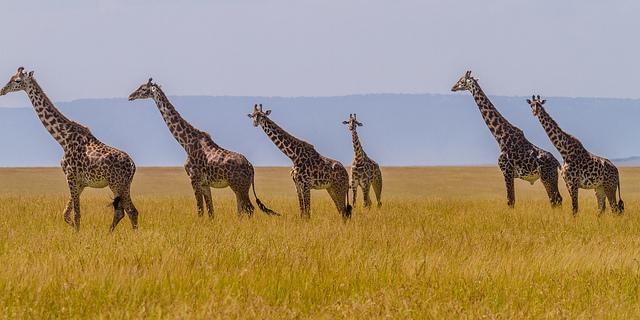How many giraffes are standing up?
Indicate the correct response and explain using: 'Answer: answer
Rationale: rationale.'
Options: Six, four, three, ten. Answer: six.
Rationale: 5 are pointing the same way and one is facing the camera 